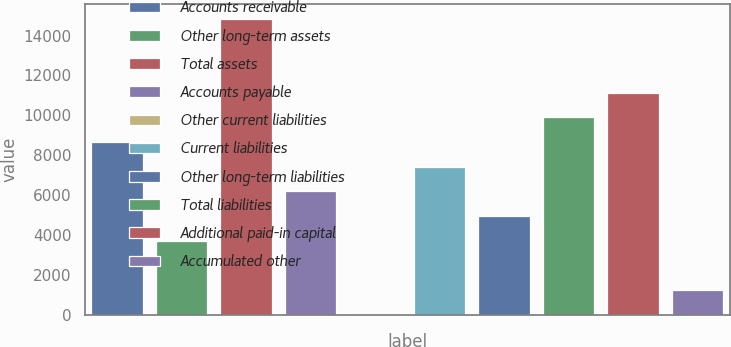Convert chart. <chart><loc_0><loc_0><loc_500><loc_500><bar_chart><fcel>Accounts receivable<fcel>Other long-term assets<fcel>Total assets<fcel>Accounts payable<fcel>Other current liabilities<fcel>Current liabilities<fcel>Other long-term liabilities<fcel>Total liabilities<fcel>Additional paid-in capital<fcel>Accumulated other<nl><fcel>8656.8<fcel>3715.2<fcel>14833.8<fcel>6186<fcel>9<fcel>7421.4<fcel>4950.6<fcel>9892.2<fcel>11127.6<fcel>1244.4<nl></chart> 